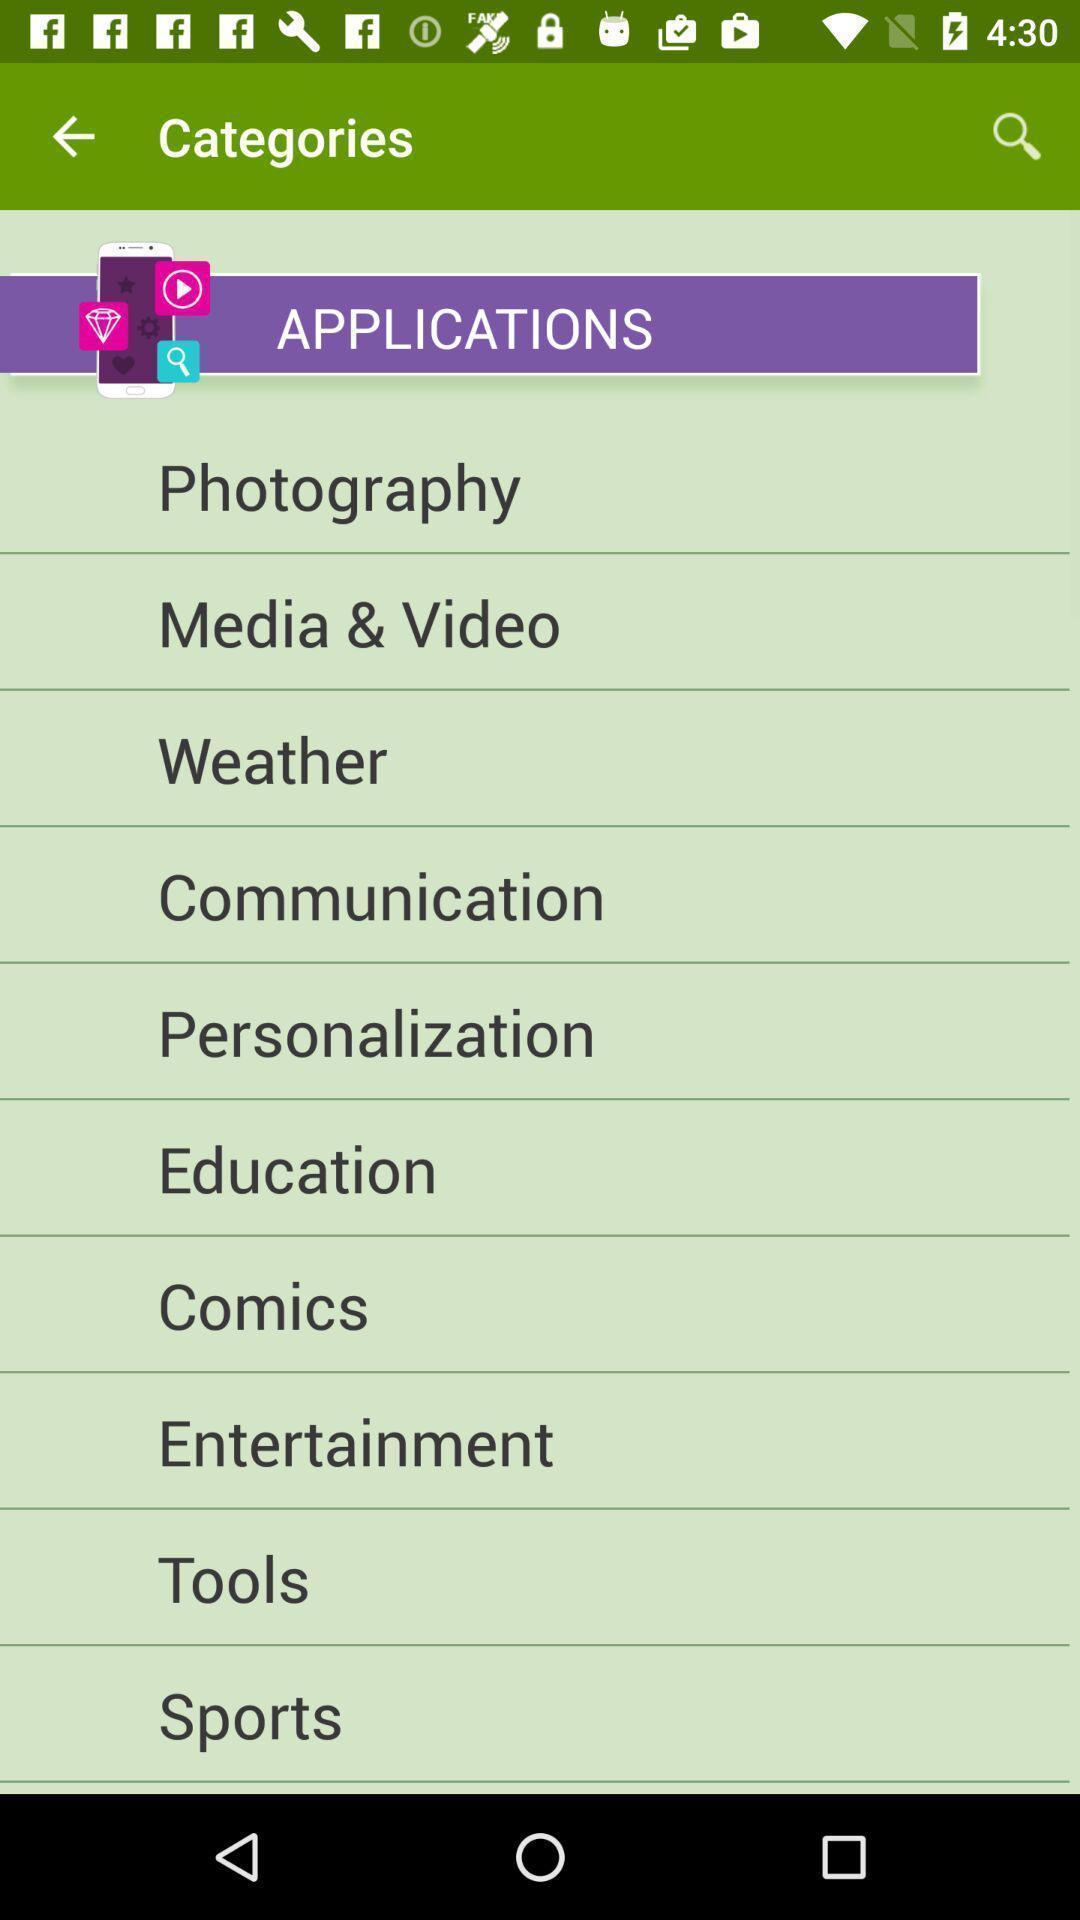What can you discern from this picture? Page displaying list of applications. 